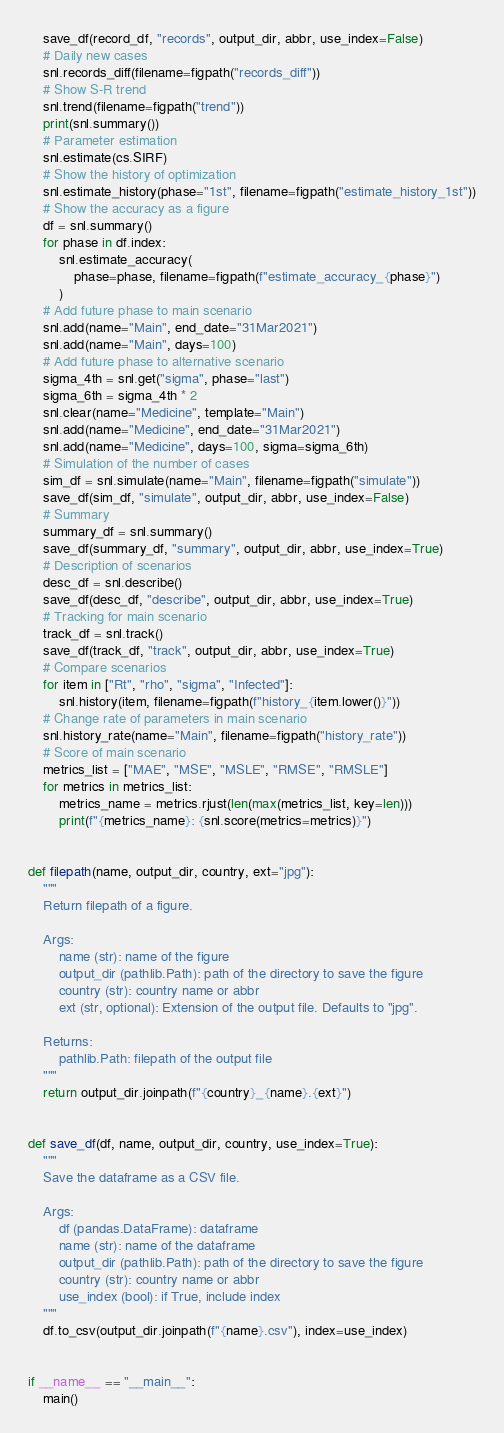<code> <loc_0><loc_0><loc_500><loc_500><_Python_>    save_df(record_df, "records", output_dir, abbr, use_index=False)
    # Daily new cases
    snl.records_diff(filename=figpath("records_diff"))
    # Show S-R trend
    snl.trend(filename=figpath("trend"))
    print(snl.summary())
    # Parameter estimation
    snl.estimate(cs.SIRF)
    # Show the history of optimization
    snl.estimate_history(phase="1st", filename=figpath("estimate_history_1st"))
    # Show the accuracy as a figure
    df = snl.summary()
    for phase in df.index:
        snl.estimate_accuracy(
            phase=phase, filename=figpath(f"estimate_accuracy_{phase}")
        )
    # Add future phase to main scenario
    snl.add(name="Main", end_date="31Mar2021")
    snl.add(name="Main", days=100)
    # Add future phase to alternative scenario
    sigma_4th = snl.get("sigma", phase="last")
    sigma_6th = sigma_4th * 2
    snl.clear(name="Medicine", template="Main")
    snl.add(name="Medicine", end_date="31Mar2021")
    snl.add(name="Medicine", days=100, sigma=sigma_6th)
    # Simulation of the number of cases
    sim_df = snl.simulate(name="Main", filename=figpath("simulate"))
    save_df(sim_df, "simulate", output_dir, abbr, use_index=False)
    # Summary
    summary_df = snl.summary()
    save_df(summary_df, "summary", output_dir, abbr, use_index=True)
    # Description of scenarios
    desc_df = snl.describe()
    save_df(desc_df, "describe", output_dir, abbr, use_index=True)
    # Tracking for main scenario
    track_df = snl.track()
    save_df(track_df, "track", output_dir, abbr, use_index=True)
    # Compare scenarios
    for item in ["Rt", "rho", "sigma", "Infected"]:
        snl.history(item, filename=figpath(f"history_{item.lower()}"))
    # Change rate of parameters in main scenario
    snl.history_rate(name="Main", filename=figpath("history_rate"))
    # Score of main scenario
    metrics_list = ["MAE", "MSE", "MSLE", "RMSE", "RMSLE"]
    for metrics in metrics_list:
        metrics_name = metrics.rjust(len(max(metrics_list, key=len)))
        print(f"{metrics_name}: {snl.score(metrics=metrics)}")


def filepath(name, output_dir, country, ext="jpg"):
    """
    Return filepath of a figure.

    Args:
        name (str): name of the figure
        output_dir (pathlib.Path): path of the directory to save the figure
        country (str): country name or abbr
        ext (str, optional): Extension of the output file. Defaults to "jpg".

    Returns:
        pathlib.Path: filepath of the output file
    """
    return output_dir.joinpath(f"{country}_{name}.{ext}")


def save_df(df, name, output_dir, country, use_index=True):
    """
    Save the dataframe as a CSV file.

    Args:
        df (pandas.DataFrame): dataframe
        name (str): name of the dataframe
        output_dir (pathlib.Path): path of the directory to save the figure
        country (str): country name or abbr
        use_index (bool): if True, include index
    """
    df.to_csv(output_dir.joinpath(f"{name}.csv"), index=use_index)


if __name__ == "__main__":
    main()
</code> 